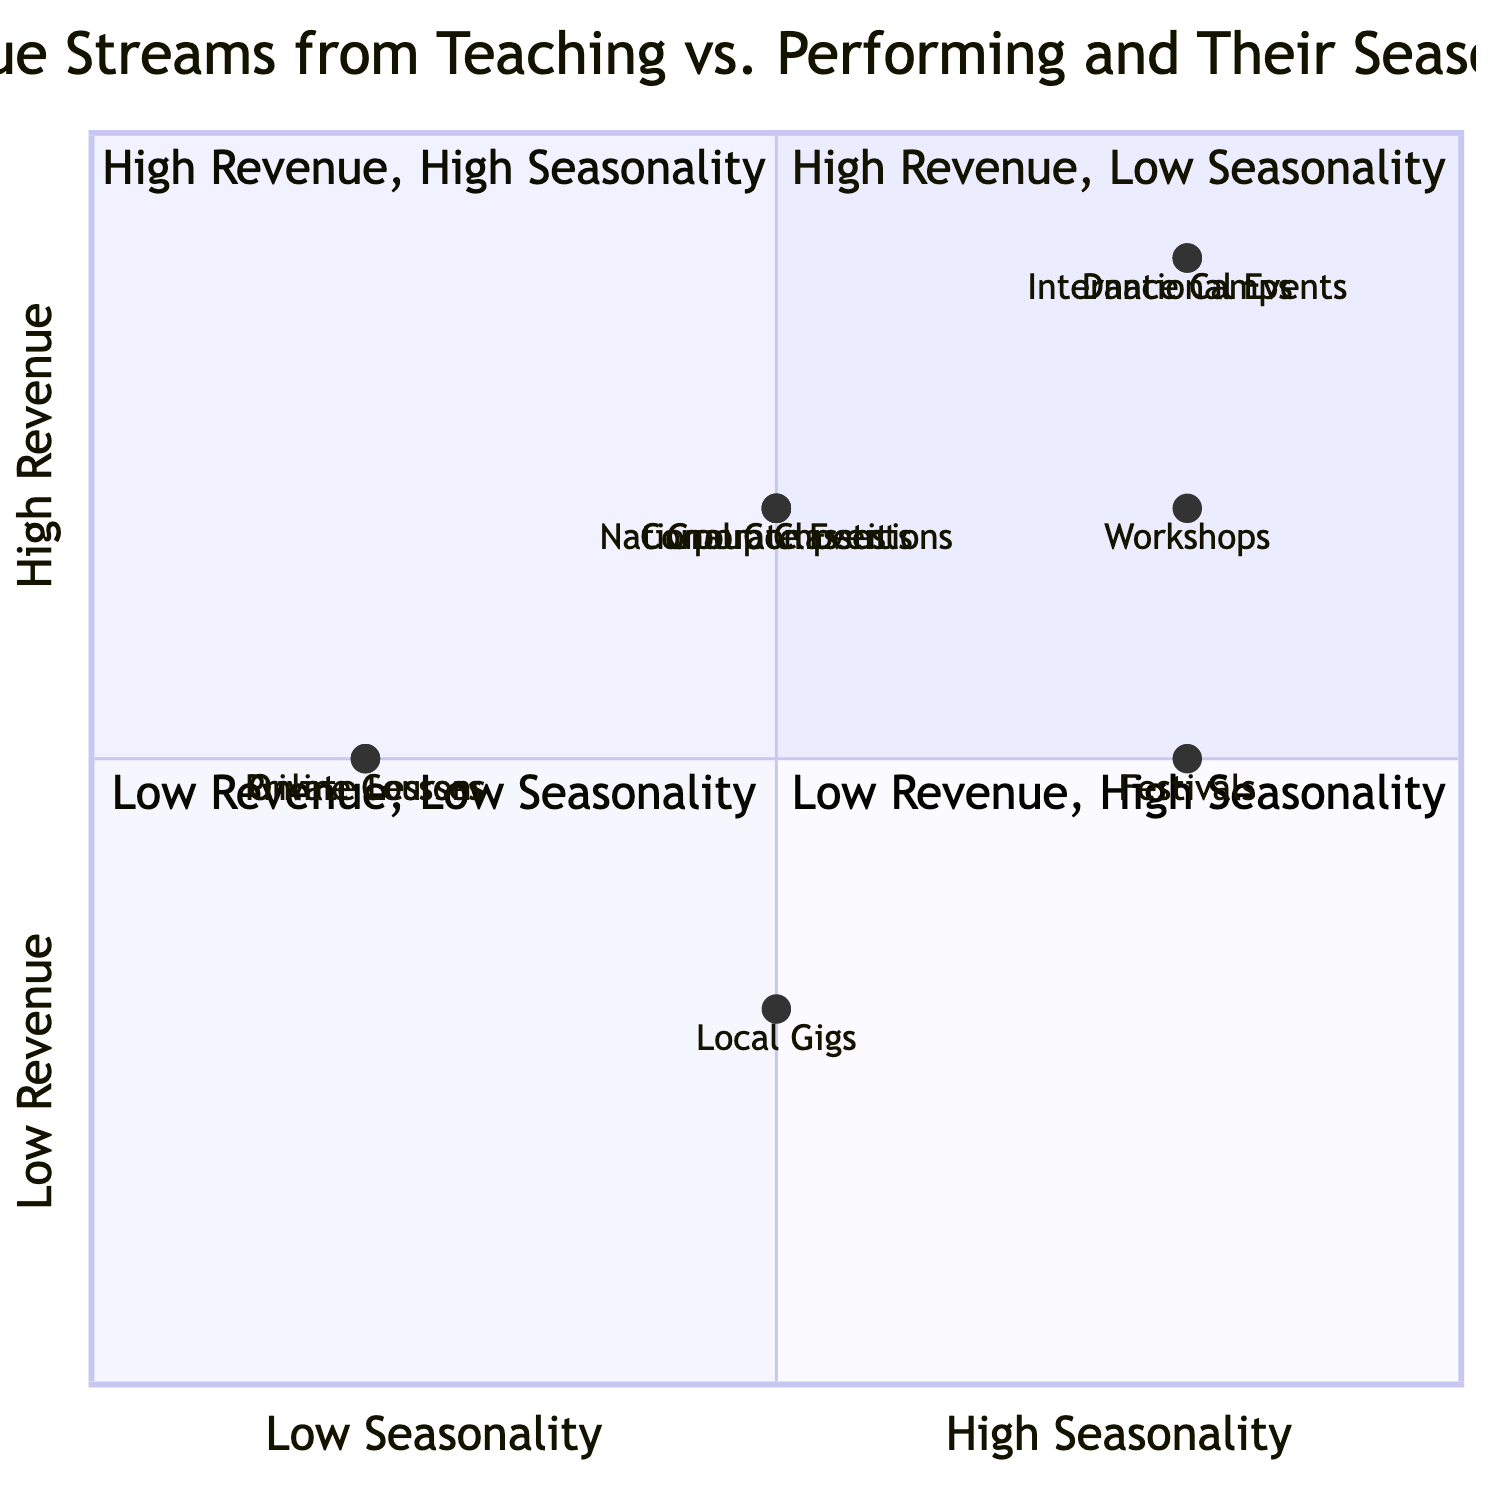What revenue level is assigned to Dance Camps? Looking at the quadrant chart, Dance Camps is positioned in quadrant 2, where it corresponds to high revenue. Thus, it is classified as "Very High".
Answer: Very High Which teaching revenue streams have low seasonality? By scanning the chart, Private Lessons, Online Courses, and Group Classes show low seasonality since they are positioned closer to the left side (low seasonality).
Answer: Private Lessons, Online Courses, Group Classes How many performing revenue streams have high seasonality? Analyzing the chart, I can count International Events, Festivals, and Local Gigs, which lie in quadrant 2 and quadrant 4. This gives us three streams with high seasonality.
Answer: Three What is the revenue level of National Competitions? National Competitions is located in quadrant 2, which indicates a high revenue level, specifically marked as "High".
Answer: High Which activity has the highest revenue among the teaching streams? Observing the quadrant chart, Dance Camps is on the very high revenue plane in quadrant 2, indicating its status as the highest amongst teaching activities.
Answer: Dance Camps Compare the revenue of Workshops with Corporate Events; which one is higher? Workshops are placed in quadrant 2, which indicates high revenue, while Corporate Events are also in quadrant 2 but classified as "High". Therefore, both have similar revenue levels but Workshops may perform slightly better in high seasonality.
Answer: Similar High Revenue Which revenue stream combines medium revenue with high seasonality? By checking the quadrant chart, Festivals from the performing revenue streams is the one that aligns with medium revenue and high seasonality.
Answer: Festivals How many revenue streams fall into quadrant 1? Quadrant 1 on the chart shows high revenue and low seasonality. Analyzing the data, the streams here include Private Lessons and Online Courses. They total two revenue streams in this quadrant.
Answer: Two What is the seasonality of Group Classes? Group Classes is located in quadrant 2, indicating that it has a medium level of seasonality based on its positioning towards the center of the X-axis.
Answer: Medium 